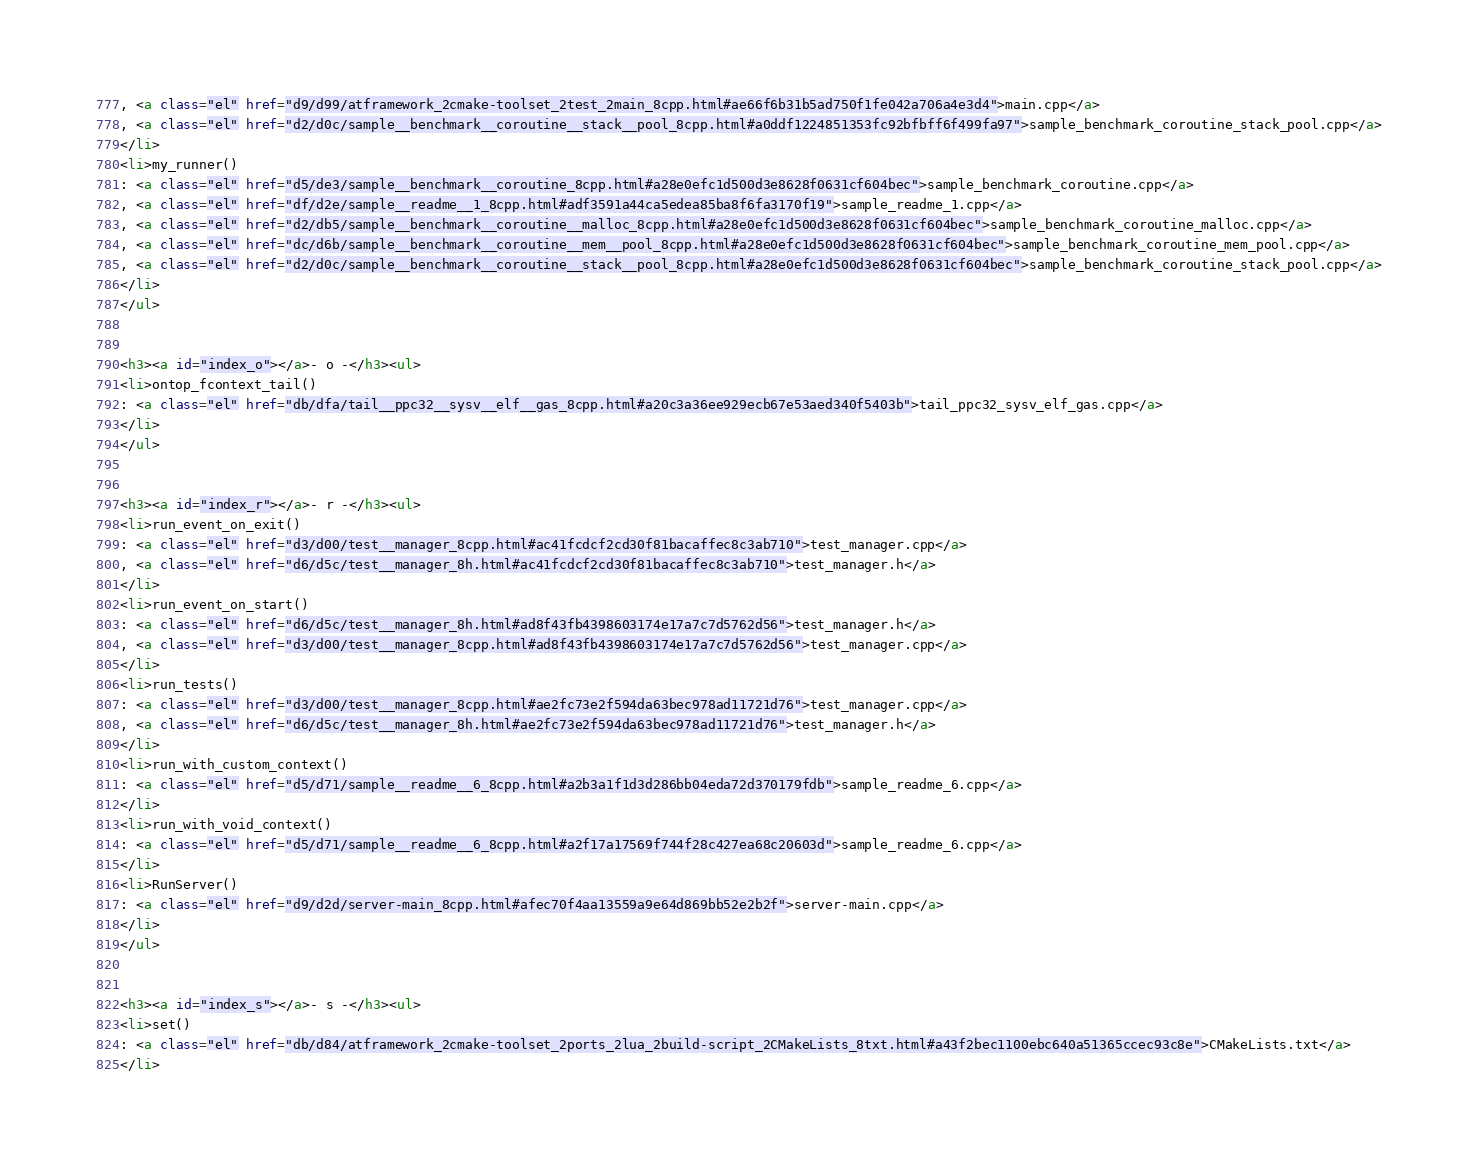Convert code to text. <code><loc_0><loc_0><loc_500><loc_500><_HTML_>, <a class="el" href="d9/d99/atframework_2cmake-toolset_2test_2main_8cpp.html#ae66f6b31b5ad750f1fe042a706a4e3d4">main.cpp</a>
, <a class="el" href="d2/d0c/sample__benchmark__coroutine__stack__pool_8cpp.html#a0ddf1224851353fc92bfbff6f499fa97">sample_benchmark_coroutine_stack_pool.cpp</a>
</li>
<li>my_runner()
: <a class="el" href="d5/de3/sample__benchmark__coroutine_8cpp.html#a28e0efc1d500d3e8628f0631cf604bec">sample_benchmark_coroutine.cpp</a>
, <a class="el" href="df/d2e/sample__readme__1_8cpp.html#adf3591a44ca5edea85ba8f6fa3170f19">sample_readme_1.cpp</a>
, <a class="el" href="d2/db5/sample__benchmark__coroutine__malloc_8cpp.html#a28e0efc1d500d3e8628f0631cf604bec">sample_benchmark_coroutine_malloc.cpp</a>
, <a class="el" href="dc/d6b/sample__benchmark__coroutine__mem__pool_8cpp.html#a28e0efc1d500d3e8628f0631cf604bec">sample_benchmark_coroutine_mem_pool.cpp</a>
, <a class="el" href="d2/d0c/sample__benchmark__coroutine__stack__pool_8cpp.html#a28e0efc1d500d3e8628f0631cf604bec">sample_benchmark_coroutine_stack_pool.cpp</a>
</li>
</ul>


<h3><a id="index_o"></a>- o -</h3><ul>
<li>ontop_fcontext_tail()
: <a class="el" href="db/dfa/tail__ppc32__sysv__elf__gas_8cpp.html#a20c3a36ee929ecb67e53aed340f5403b">tail_ppc32_sysv_elf_gas.cpp</a>
</li>
</ul>


<h3><a id="index_r"></a>- r -</h3><ul>
<li>run_event_on_exit()
: <a class="el" href="d3/d00/test__manager_8cpp.html#ac41fcdcf2cd30f81bacaffec8c3ab710">test_manager.cpp</a>
, <a class="el" href="d6/d5c/test__manager_8h.html#ac41fcdcf2cd30f81bacaffec8c3ab710">test_manager.h</a>
</li>
<li>run_event_on_start()
: <a class="el" href="d6/d5c/test__manager_8h.html#ad8f43fb4398603174e17a7c7d5762d56">test_manager.h</a>
, <a class="el" href="d3/d00/test__manager_8cpp.html#ad8f43fb4398603174e17a7c7d5762d56">test_manager.cpp</a>
</li>
<li>run_tests()
: <a class="el" href="d3/d00/test__manager_8cpp.html#ae2fc73e2f594da63bec978ad11721d76">test_manager.cpp</a>
, <a class="el" href="d6/d5c/test__manager_8h.html#ae2fc73e2f594da63bec978ad11721d76">test_manager.h</a>
</li>
<li>run_with_custom_context()
: <a class="el" href="d5/d71/sample__readme__6_8cpp.html#a2b3a1f1d3d286bb04eda72d370179fdb">sample_readme_6.cpp</a>
</li>
<li>run_with_void_context()
: <a class="el" href="d5/d71/sample__readme__6_8cpp.html#a2f17a17569f744f28c427ea68c20603d">sample_readme_6.cpp</a>
</li>
<li>RunServer()
: <a class="el" href="d9/d2d/server-main_8cpp.html#afec70f4aa13559a9e64d869bb52e2b2f">server-main.cpp</a>
</li>
</ul>


<h3><a id="index_s"></a>- s -</h3><ul>
<li>set()
: <a class="el" href="db/d84/atframework_2cmake-toolset_2ports_2lua_2build-script_2CMakeLists_8txt.html#a43f2bec1100ebc640a51365ccec93c8e">CMakeLists.txt</a>
</li></code> 